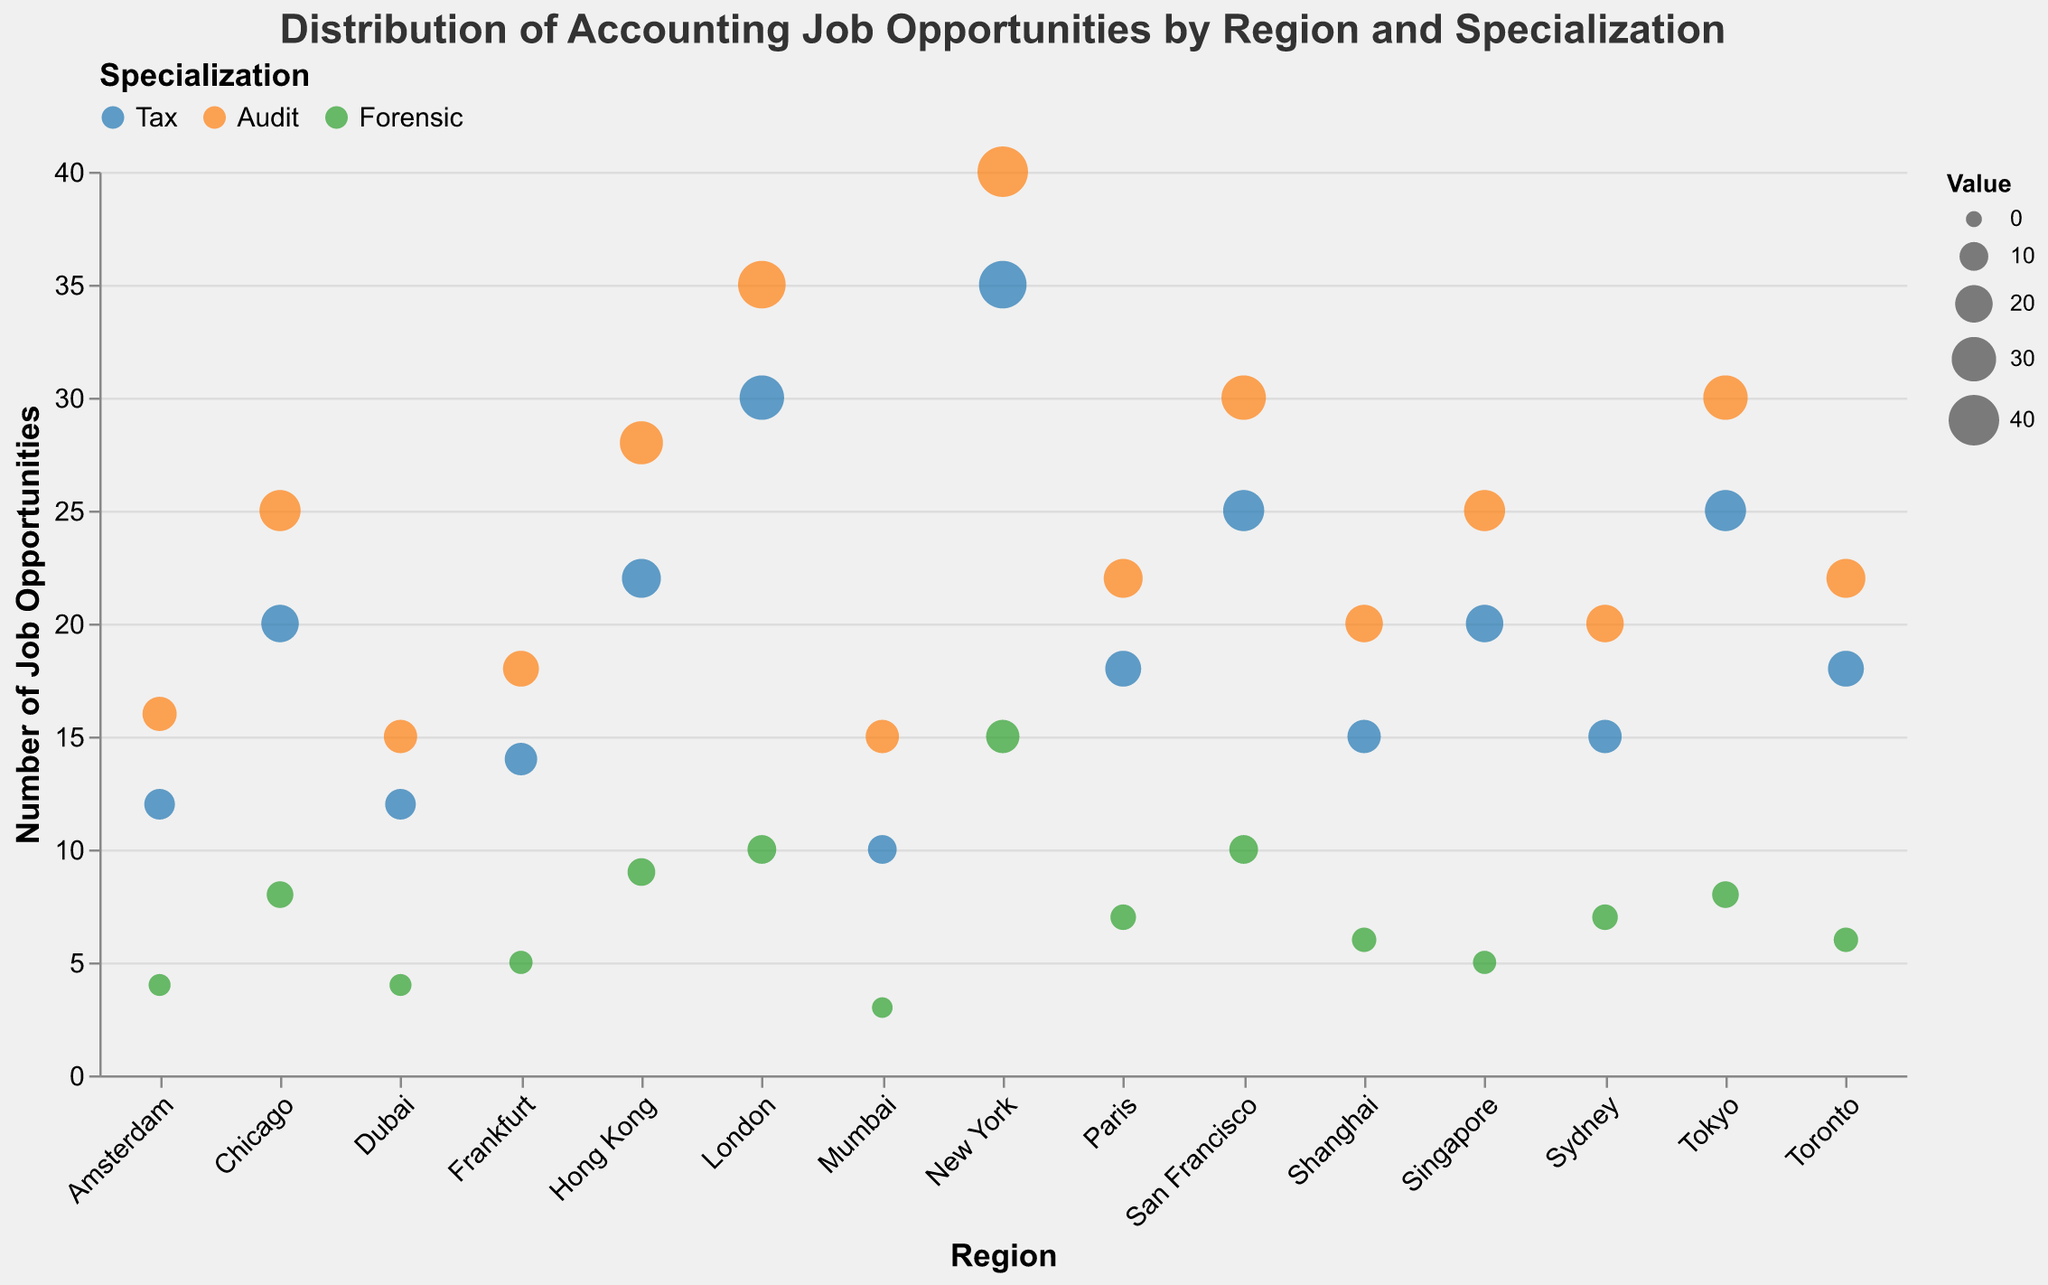What's the title of the figure? The title can be found at the top of the figure, usually set off in larger or bold text. Here it reads "Distribution of Accounting Job Opportunities by Region and Specialization".
Answer: Distribution of Accounting Job Opportunities by Region and Specialization Which region has the highest number of audit job opportunities? By looking at the circles representing audit job opportunities (orange), New York has the highest value with 40 opportunities.
Answer: New York What are the three specializations shown in the plot? The legend at the top of the figure categorizes the job opportunities into three specializations: Tax, Audit, and Forensic. These are also indicated by different circle colors.
Answer: Tax, Audit, Forensic How many total accounting job opportunities are there in London? We need to sum the job opportunities for each specialization in London: 30 (Tax) + 35 (Audit) + 10 (Forensic).
Answer: 75 Which region has the smallest number of forensic job opportunities? By comparing the green circles for forensic job opportunities, the smallest value is in Mumbai, with 3 opportunities.
Answer: Mumbai Compare the number of audit job opportunities between San Francisco and Tokyo. Which has more and by how much? San Francisco has 30 audit opportunities while Tokyo has 30. Subtract to find the difference, which is 0.
Answer: They are equal Which region has a total of less than 40 job opportunities? To find the regions, sum the values for each region, and check if the total is less than 40. Dubai has (12 + 15 + 4 = 31) and Amsterdam has (12 + 16 + 4 = 32). Both meet the criteria.
Answer: Dubai, Amsterdam What's the average number of tax job opportunities across all regions? Add the Tax opportunities for all regions: 35 + 30 + 25 + 20 + 15 + 18 + 12 + 14 + 22 + 20 + 25 + 10 + 15 + 18 + 12 = 291. Then divide by the number of regions (15): 291 / 15 = 19.4.
Answer: 19.4 Which region has more tax job opportunities, Paris or Shanghai? From the figure, Paris has 18 tax opportunities and Shanghai has 15. Paris has more opportunities.
Answer: Paris If you want to focus on forensic accounting, which three regions should you consider for the highest job opportunities? Identify the three highest values in forensic accounting. New York with 15, London with 10, and San Francisco with 10 have the highest forensic opportunities.
Answer: New York, London, San Francisco 